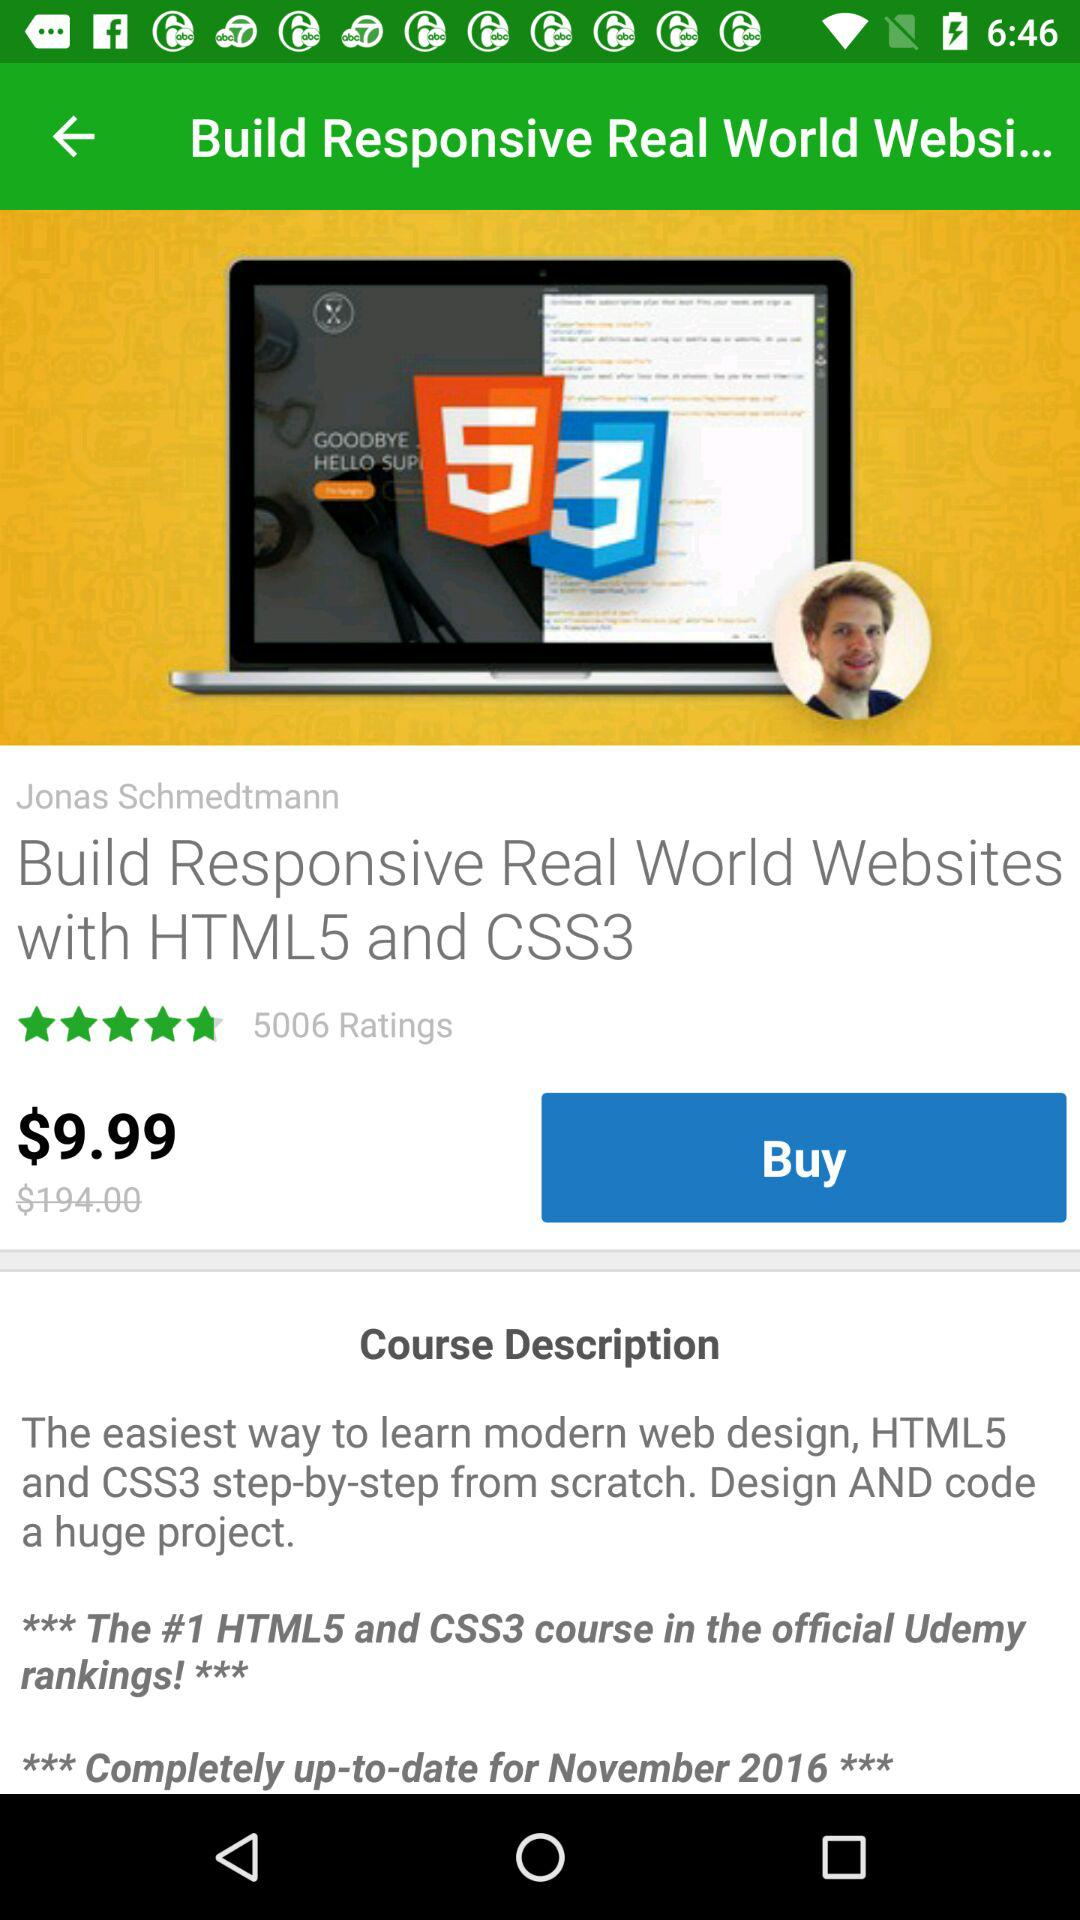How many reviews are there? There are 5006 reviews. 